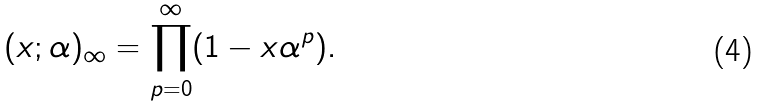<formula> <loc_0><loc_0><loc_500><loc_500>( x ; \alpha ) _ { \infty } = \prod _ { p = 0 } ^ { \infty } ( 1 - x \alpha ^ { p } ) .</formula> 